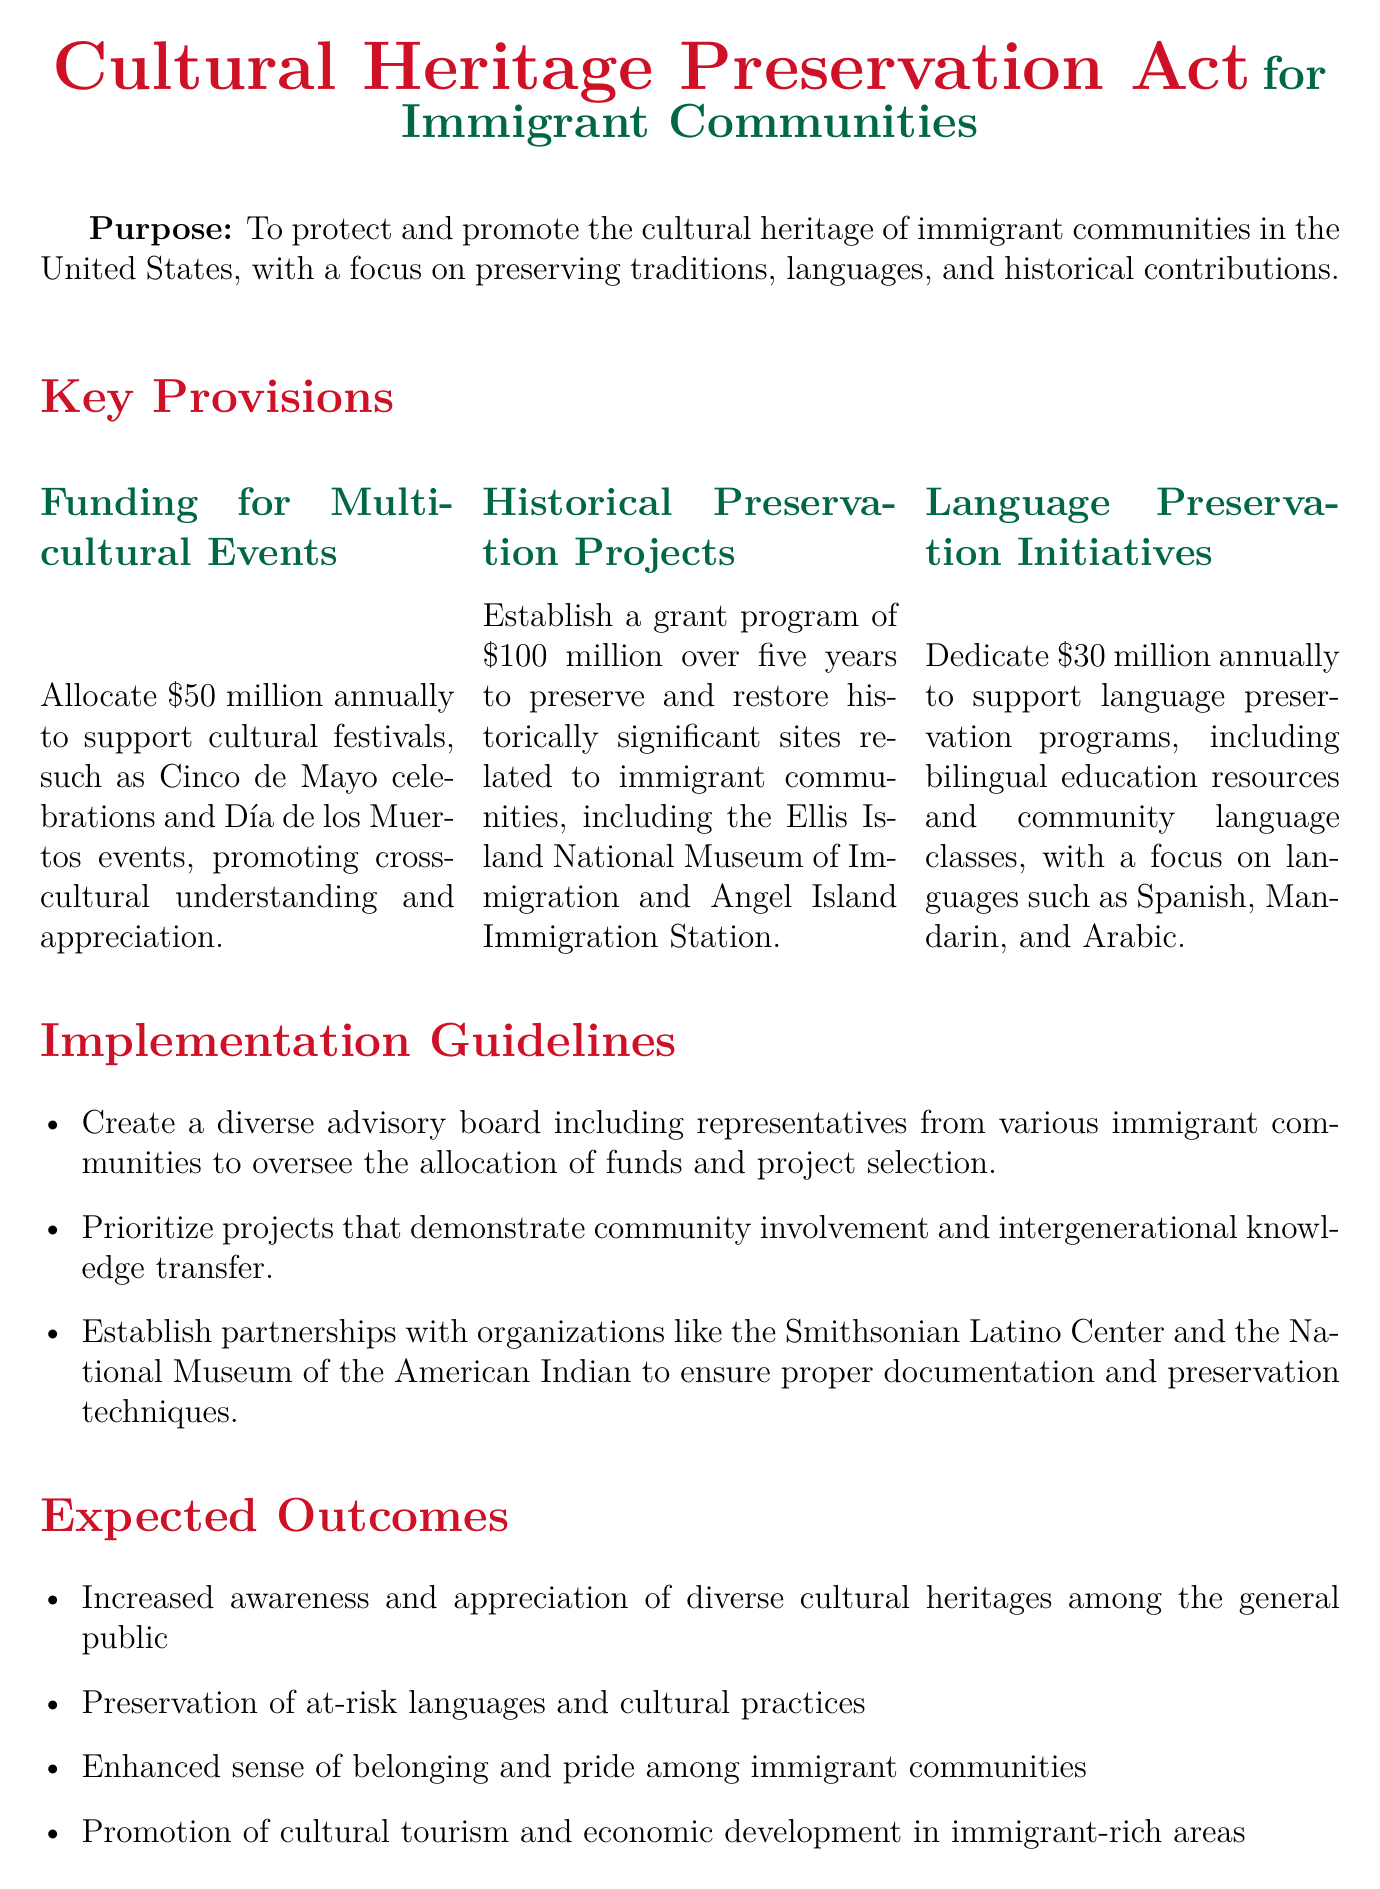What is the annual funding for multicultural events? The document specifies that $50 million will be allocated annually for multicultural events.
Answer: $50 million How much funding is dedicated to language preservation programs annually? According to the guidelines, $30 million is dedicated annually to language preservation programs.
Answer: $30 million What is the total amount allocated for historical preservation projects over five years? The document mentions a grant program of $100 million over five years for preserving historical sites.
Answer: $100 million Which community's heritage is highlighted in the relevant case study? The case study focuses on the preservation of Cuban-American heritage in Little Havana.
Answer: Cuban-American What is one expected outcome of the Cultural Heritage Preservation Act? One of the expected outcomes is the preservation of at-risk languages and cultural practices.
Answer: Preservation of at-risk languages and cultural practices What type of board is to be created for oversight of the funds? The document states that a diverse advisory board will be created to oversee the allocation of funds.
Answer: Diverse advisory board Which organization is mentioned as a potential partner in the implementation guidelines? The Smithsonian Latino Center is one of the organizations mentioned for partnerships.
Answer: Smithsonian Latino Center What is the purpose of the Cultural Heritage Preservation Act? The purpose is to protect and promote the cultural heritage of immigrant communities.
Answer: Protect and promote the cultural heritage of immigrant communities 